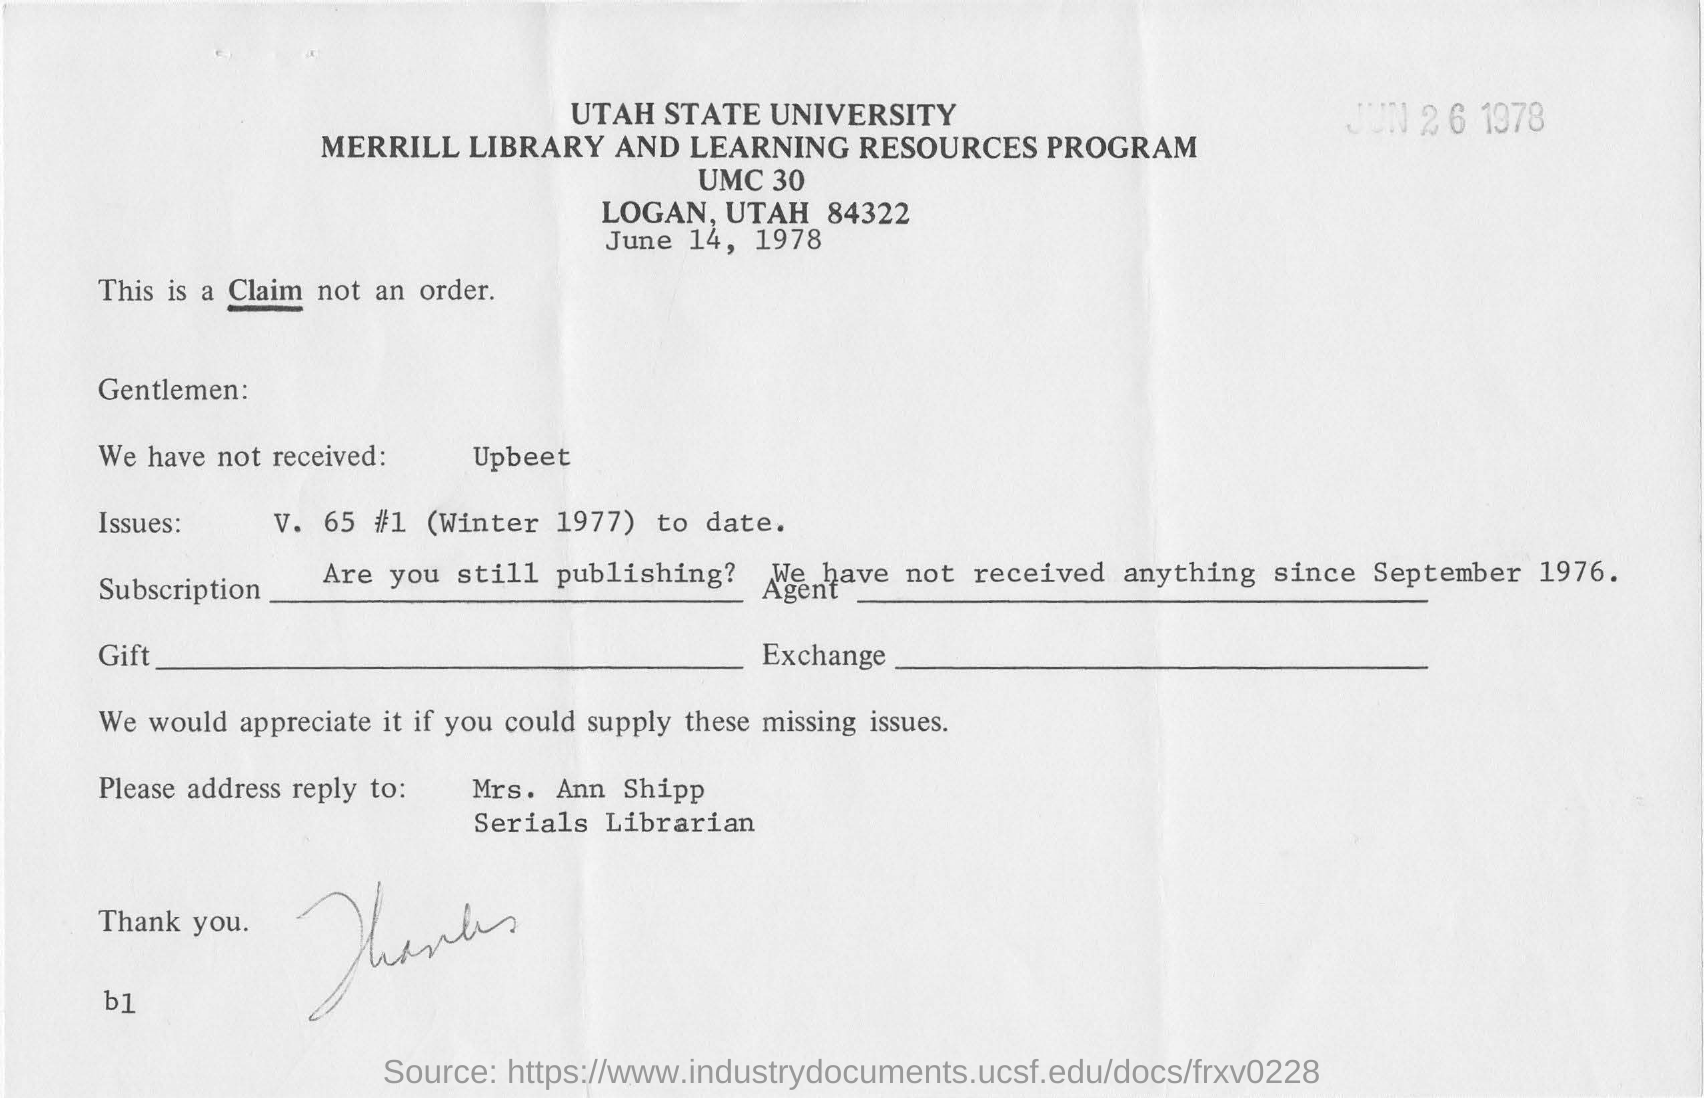What is the date mentioned in this document?
Make the answer very short. June 14, 1978. What is the university name mentioned in the document?
Keep it short and to the point. UTAH STATE UNIVERSITY. What is the name of the librarian?
Offer a terse response. MRS. ANN SHIPP. What is the designation of Mrs. Ann Shipp?
Your answer should be compact. Serials librarian. 